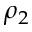<formula> <loc_0><loc_0><loc_500><loc_500>\rho _ { 2 }</formula> 